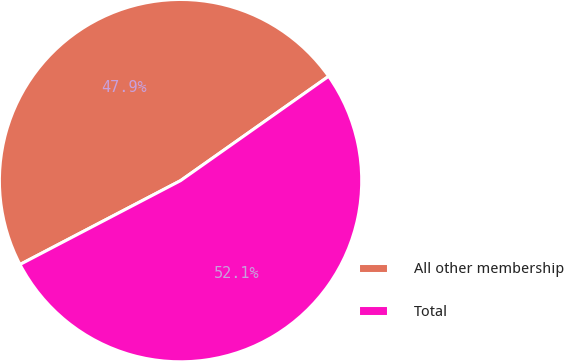Convert chart. <chart><loc_0><loc_0><loc_500><loc_500><pie_chart><fcel>All other membership<fcel>Total<nl><fcel>47.89%<fcel>52.11%<nl></chart> 